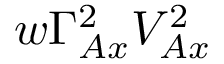Convert formula to latex. <formula><loc_0><loc_0><loc_500><loc_500>w \Gamma _ { A x } ^ { 2 } V _ { A x } ^ { 2 }</formula> 